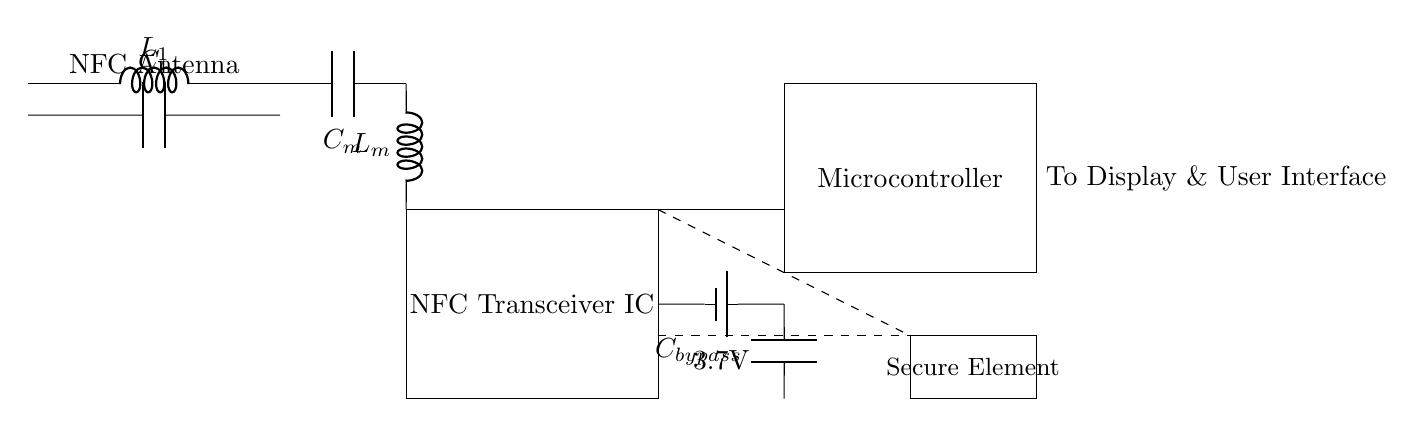What is the primary function of the circuit? The primary function is to enable near-field communication for mobile payments, utilizing an NFC antenna and transceiver.
Answer: mobile payments What voltage does the battery provide? The battery is labeled with a voltage of 3.7V, indicating the power supply's output.
Answer: 3.7V What components are included in the matching network? The matching network consists of a capacitor labeled C sub m and an inductor labeled L sub m, used for impedance matching.
Answer: C sub m and L sub m What is the role of the microcontroller in this circuit? The microcontroller coordinates communication and operations within the NFC circuit, managing data processing and control.
Answer: data processing How many major sections are visible in the circuit? There are three major sections visible: the NFC antenna, matching network, and the NFC transceiver IC, along with power management and secure element.
Answer: three What is connected to the NFC transceiver IC? The microcontroller connects to the NFC transceiver IC to facilitate communication and control within the circuit.
Answer: microcontroller Which component acts as a power filter in this circuit? The component labeled C sub bypass serves as a filter to stabilize power supply to the NFC transceiver IC.
Answer: C sub bypass 